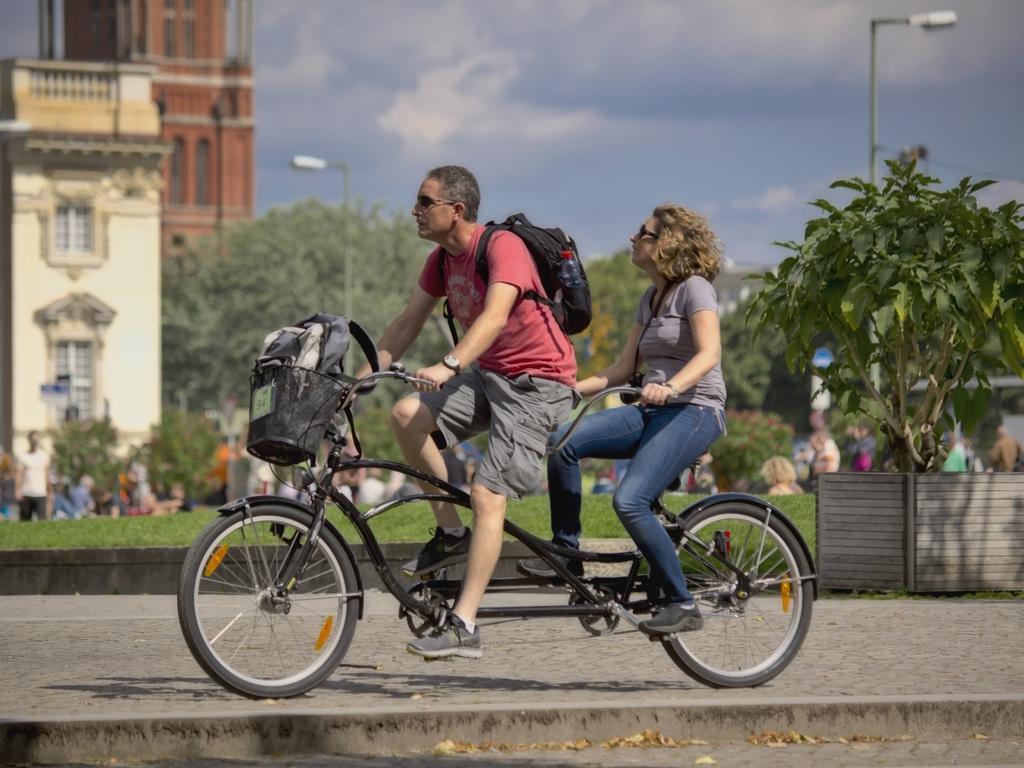Can you describe this image briefly? In this picture , there is a man and a woman both are riding a cycle, there man wearing a pink shirt is wearing a black color bag and there is another bag in front of the cycle basket they are riding on the footpath beside them there is a grass , in the background there is building, street lights ,trees, sky and clouds and also some other people. 